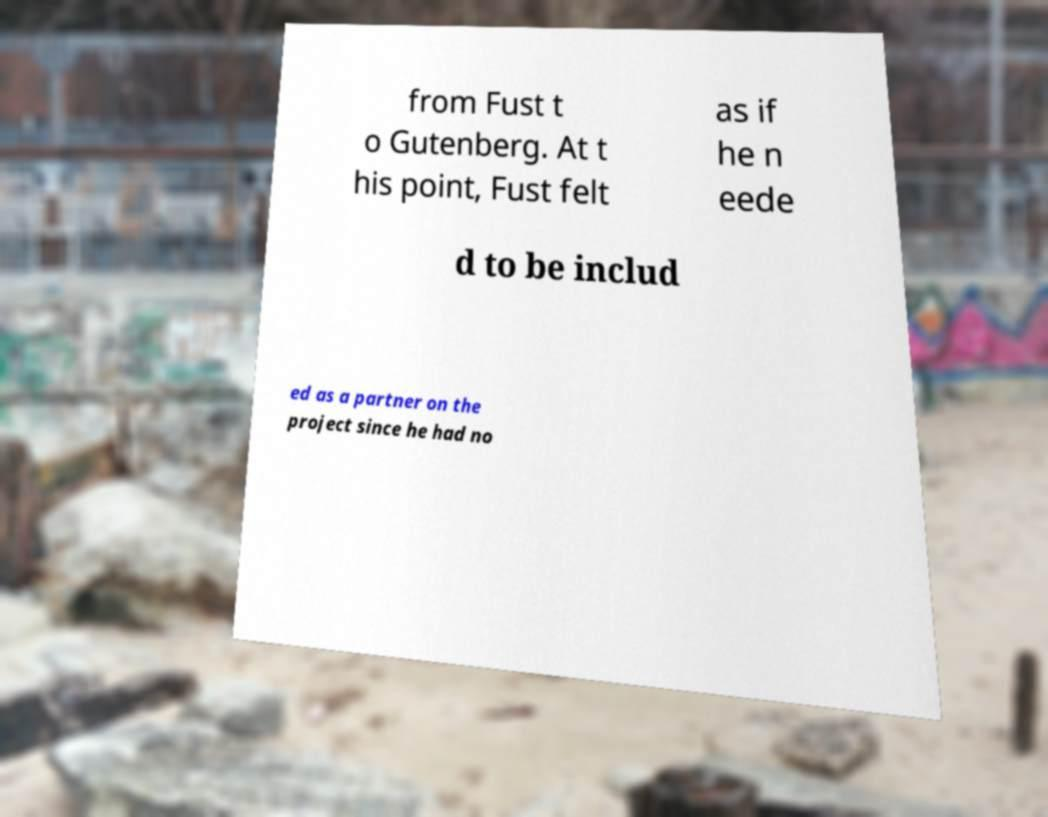Can you read and provide the text displayed in the image?This photo seems to have some interesting text. Can you extract and type it out for me? from Fust t o Gutenberg. At t his point, Fust felt as if he n eede d to be includ ed as a partner on the project since he had no 